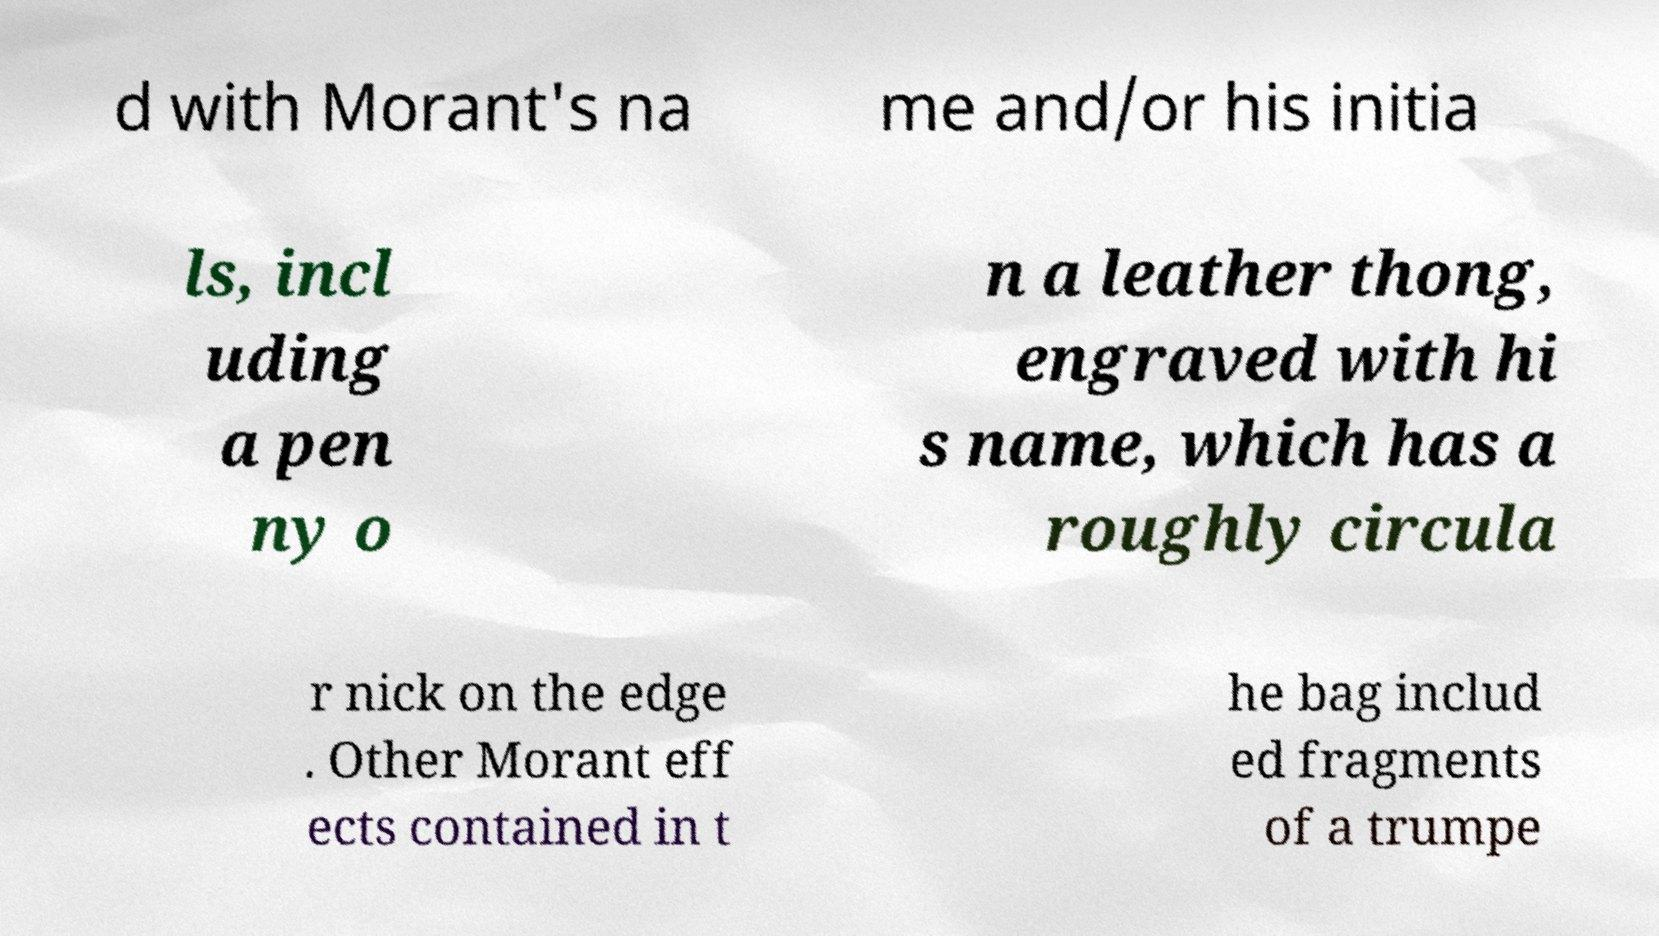Could you extract and type out the text from this image? d with Morant's na me and/or his initia ls, incl uding a pen ny o n a leather thong, engraved with hi s name, which has a roughly circula r nick on the edge . Other Morant eff ects contained in t he bag includ ed fragments of a trumpe 